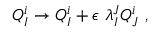<formula> <loc_0><loc_0><loc_500><loc_500>Q _ { I } ^ { i } \to Q _ { I } ^ { i } + \epsilon \ \lambda _ { I } ^ { J } Q _ { J } ^ { i } ,</formula> 